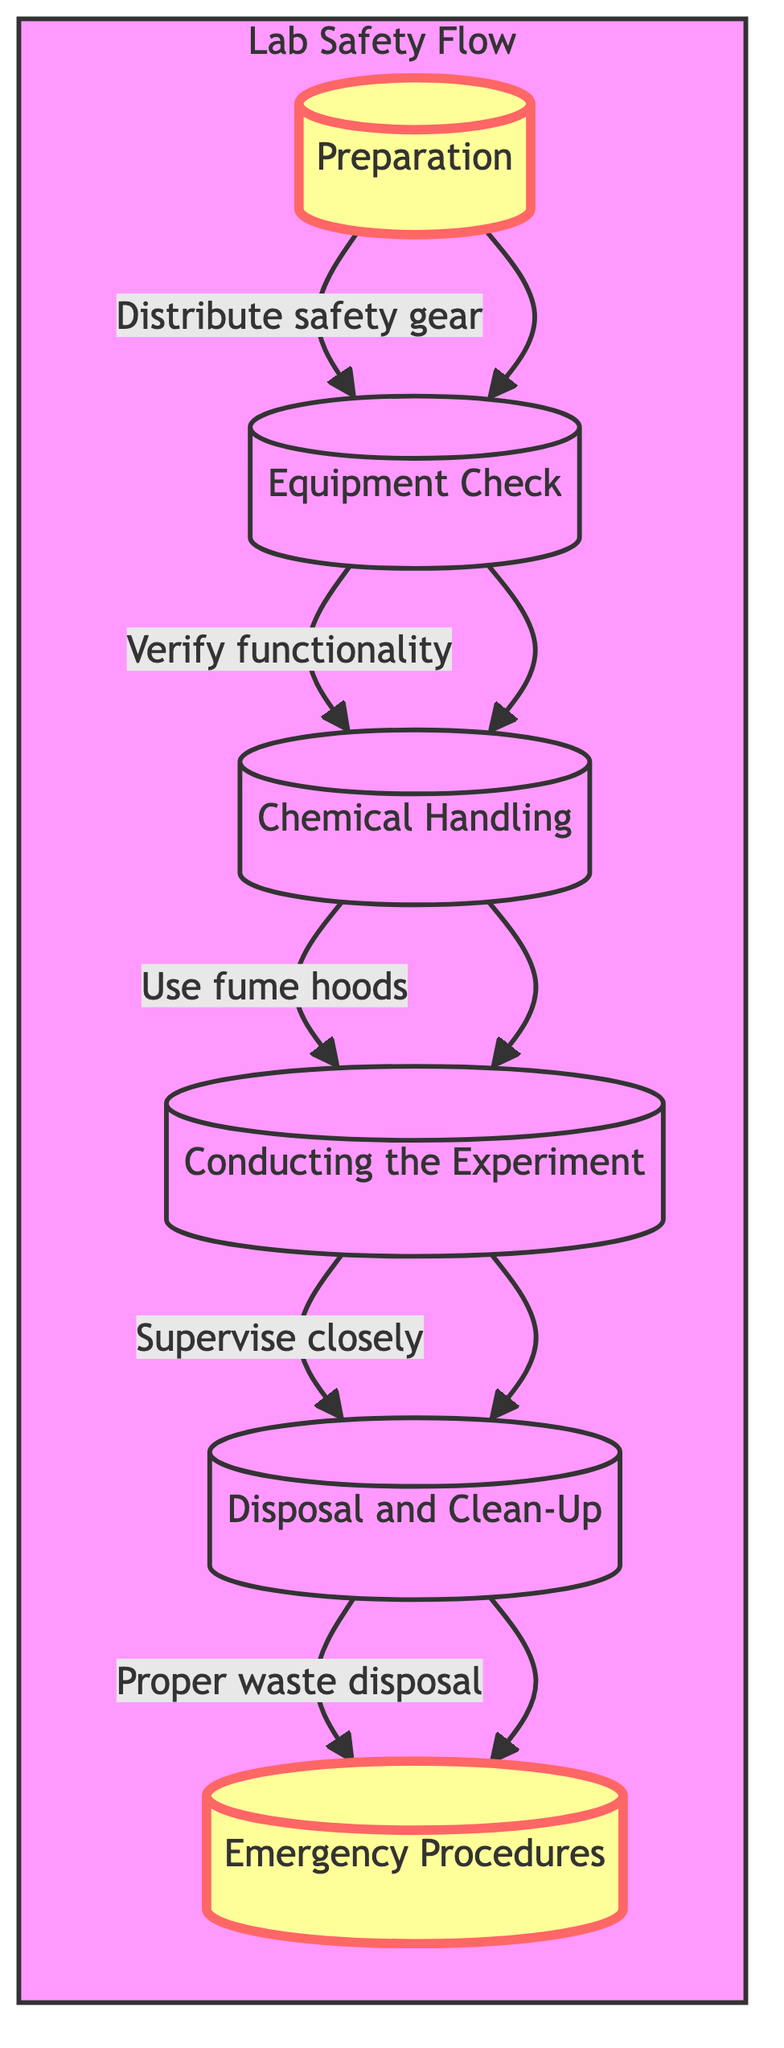What is the first step in the flowchart? The flowchart begins with the "Preparation" node, which is the initial step where students are made aware of safety protocols.
Answer: Preparation How many nodes are present in the flowchart? The flowchart contains six distinct nodes, each representing a specific step in the lab safety procedures.
Answer: 6 What is the last step in the flowchart? The final step of the flowchart is "Emergency Procedures", which details how to handle emergencies and locate safety equipment.
Answer: Emergency Procedures Which node follows "Chemical Handling"? The node that follows "Chemical Handling" is "Conducting the Experiment", indicating that after handling chemicals properly, the experiment can be conducted.
Answer: Conducting the Experiment What is the key phrase associated with the arrow between "Preparation" and "Equipment Check"? The connection from "Preparation" to "Equipment Check" is associated with the phrase "Distribute safety gear", indicating what is done to transition from the first step to the second.
Answer: Distribute safety gear What type of equipment is located in the last step? In the last step, "Emergency Procedures", the focus is on several emergency equipment locations including the eye wash station and fire extinguisher.
Answer: Emergency equipment What indicates the connection between "Conducting the Experiment" and "Disposal and Clean-Up"? The arrow between "Conducting the Experiment" and "Disposal and Clean-Up" is labeled as "Proper waste disposal," indicating the action required after the experiment is completed.
Answer: Proper waste disposal What is emphasized in the diagram? The "Preparation" and "Emergency Procedures" nodes are emphasized in the diagram, highlighting their importance in the safety protocol.
Answer: Preparation, Emergency Procedures How do the arrows between nodes contribute to the flowchart? The arrows establish the sequential relationship between the nodes, showing the order in which each step must be followed in lab safety procedures.
Answer: Sequential relationship 